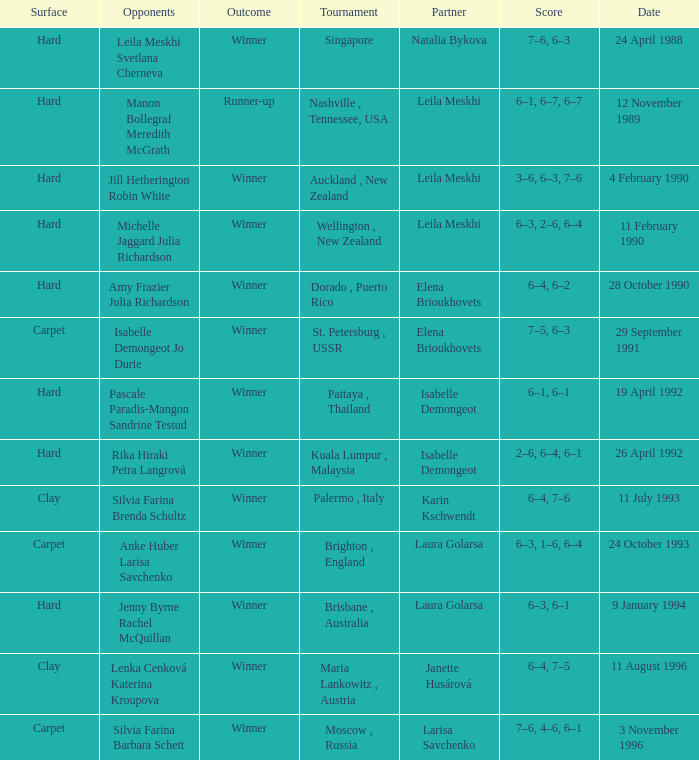Can you parse all the data within this table? {'header': ['Surface', 'Opponents', 'Outcome', 'Tournament', 'Partner', 'Score', 'Date'], 'rows': [['Hard', 'Leila Meskhi Svetlana Cherneva', 'Winner', 'Singapore', 'Natalia Bykova', '7–6, 6–3', '24 April 1988'], ['Hard', 'Manon Bollegraf Meredith McGrath', 'Runner-up', 'Nashville , Tennessee, USA', 'Leila Meskhi', '6–1, 6–7, 6–7', '12 November 1989'], ['Hard', 'Jill Hetherington Robin White', 'Winner', 'Auckland , New Zealand', 'Leila Meskhi', '3–6, 6–3, 7–6', '4 February 1990'], ['Hard', 'Michelle Jaggard Julia Richardson', 'Winner', 'Wellington , New Zealand', 'Leila Meskhi', '6–3, 2–6, 6–4', '11 February 1990'], ['Hard', 'Amy Frazier Julia Richardson', 'Winner', 'Dorado , Puerto Rico', 'Elena Brioukhovets', '6–4, 6–2', '28 October 1990'], ['Carpet', 'Isabelle Demongeot Jo Durie', 'Winner', 'St. Petersburg , USSR', 'Elena Brioukhovets', '7–5, 6–3', '29 September 1991'], ['Hard', 'Pascale Paradis-Mangon Sandrine Testud', 'Winner', 'Pattaya , Thailand', 'Isabelle Demongeot', '6–1, 6–1', '19 April 1992'], ['Hard', 'Rika Hiraki Petra Langrová', 'Winner', 'Kuala Lumpur , Malaysia', 'Isabelle Demongeot', '2–6, 6–4, 6–1', '26 April 1992'], ['Clay', 'Silvia Farina Brenda Schultz', 'Winner', 'Palermo , Italy', 'Karin Kschwendt', '6–4, 7–6', '11 July 1993'], ['Carpet', 'Anke Huber Larisa Savchenko', 'Winner', 'Brighton , England', 'Laura Golarsa', '6–3, 1–6, 6–4', '24 October 1993'], ['Hard', 'Jenny Byrne Rachel McQuillan', 'Winner', 'Brisbane , Australia', 'Laura Golarsa', '6–3, 6–1', '9 January 1994'], ['Clay', 'Lenka Cenková Katerina Kroupova', 'Winner', 'Maria Lankowitz , Austria', 'Janette Husárová', '6–4, 7–5', '11 August 1996'], ['Carpet', 'Silvia Farina Barbara Schett', 'Winner', 'Moscow , Russia', 'Larisa Savchenko', '7–6, 4–6, 6–1', '3 November 1996']]} On what day was the score 6-4, 6-2? 28 October 1990. 